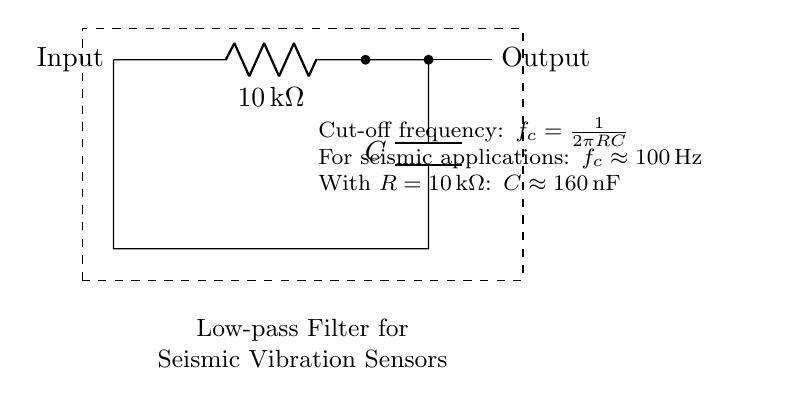What type of filter is represented in this circuit? The circuit is a low-pass filter, which allows signals below a certain frequency to pass while attenuating higher frequencies. This is indicated by the use of a resistor and capacitor in the arrangement designed to set a cut-off frequency.
Answer: Low-pass filter What is the value of the resistor in this circuit? The resistor is labeled as ten kilohms, which is typical for filtering applications to prevent noise while allowing seismic signals through. This value is explicitly shown in the labeled component of the circuit diagram.
Answer: Ten kilohms What is the cut-off frequency for this filter? The cut-off frequency can be calculated as approximated at one hundred hertz based on the standard operation of seismic filters, as indicated in the accompanying information.
Answer: One hundred hertz How does the capacitance value relate to the cut-off frequency? The capacitance is approximately one hundred sixty nanofarads and is derived from the cut-off frequency formula, emphasizing that lower capacitance would raise the cut-off frequency. We find this relationship through the formula involving the product of resistance and capacitance.
Answer: One hundred sixty nanofarads What happens to signals above the cut-off frequency in this circuit? Signals above the cut-off frequency are attenuated or reduced, preventing high-frequency noise from interfering with the measurements from seismic vibration sensors, as intended for this application. This behavior is a characteristic function of low-pass filters.
Answer: Attenuated 